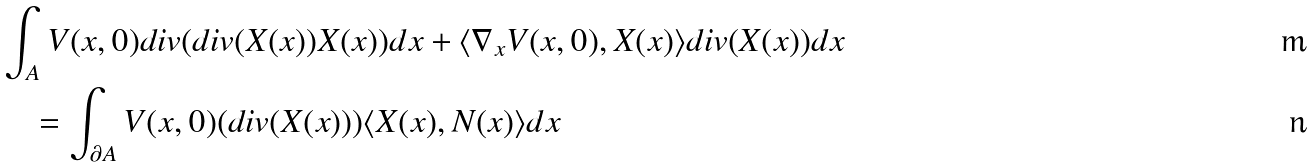Convert formula to latex. <formula><loc_0><loc_0><loc_500><loc_500>& \int _ { A } V ( x , 0 ) d i v ( d i v ( X ( x ) ) X ( x ) ) d x + \langle \nabla _ { x } V ( x , 0 ) , X ( x ) \rangle d i v ( X ( x ) ) d x \\ & \quad = \int _ { \partial A } V ( x , 0 ) ( d i v ( X ( x ) ) ) \langle X ( x ) , N ( x ) \rangle d x</formula> 